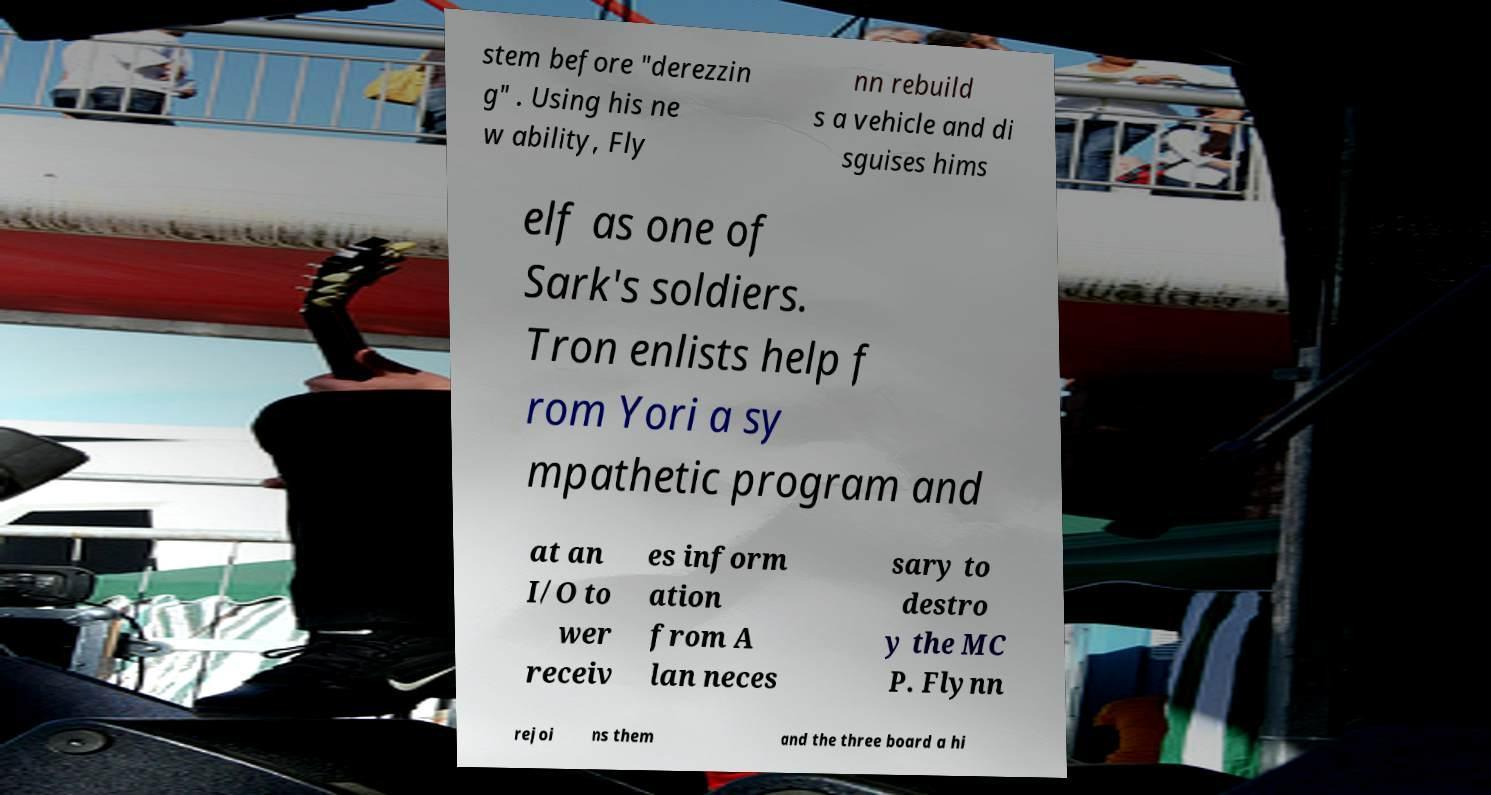For documentation purposes, I need the text within this image transcribed. Could you provide that? stem before "derezzin g" . Using his ne w ability, Fly nn rebuild s a vehicle and di sguises hims elf as one of Sark's soldiers. Tron enlists help f rom Yori a sy mpathetic program and at an I/O to wer receiv es inform ation from A lan neces sary to destro y the MC P. Flynn rejoi ns them and the three board a hi 